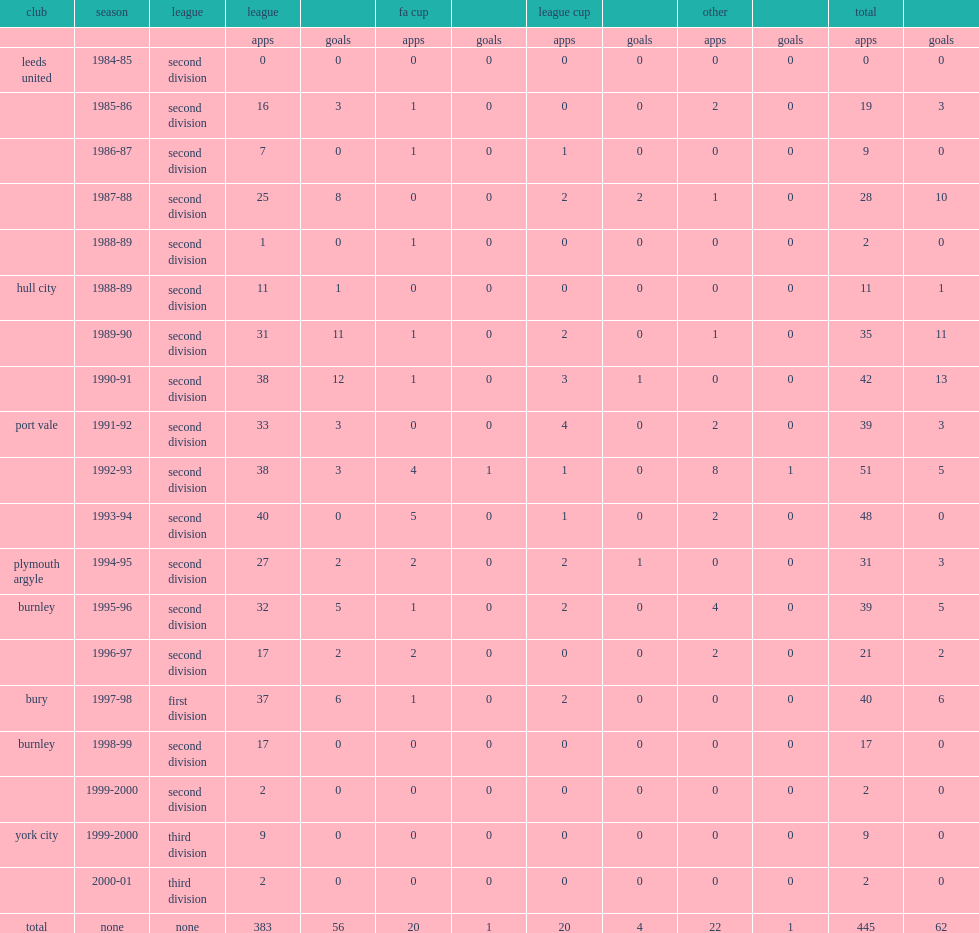How many goals did peter swan score in his career in the football league? 62.0. Would you be able to parse every entry in this table? {'header': ['club', 'season', 'league', 'league', '', 'fa cup', '', 'league cup', '', 'other', '', 'total', ''], 'rows': [['', '', '', 'apps', 'goals', 'apps', 'goals', 'apps', 'goals', 'apps', 'goals', 'apps', 'goals'], ['leeds united', '1984-85', 'second division', '0', '0', '0', '0', '0', '0', '0', '0', '0', '0'], ['', '1985-86', 'second division', '16', '3', '1', '0', '0', '0', '2', '0', '19', '3'], ['', '1986-87', 'second division', '7', '0', '1', '0', '1', '0', '0', '0', '9', '0'], ['', '1987-88', 'second division', '25', '8', '0', '0', '2', '2', '1', '0', '28', '10'], ['', '1988-89', 'second division', '1', '0', '1', '0', '0', '0', '0', '0', '2', '0'], ['hull city', '1988-89', 'second division', '11', '1', '0', '0', '0', '0', '0', '0', '11', '1'], ['', '1989-90', 'second division', '31', '11', '1', '0', '2', '0', '1', '0', '35', '11'], ['', '1990-91', 'second division', '38', '12', '1', '0', '3', '1', '0', '0', '42', '13'], ['port vale', '1991-92', 'second division', '33', '3', '0', '0', '4', '0', '2', '0', '39', '3'], ['', '1992-93', 'second division', '38', '3', '4', '1', '1', '0', '8', '1', '51', '5'], ['', '1993-94', 'second division', '40', '0', '5', '0', '1', '0', '2', '0', '48', '0'], ['plymouth argyle', '1994-95', 'second division', '27', '2', '2', '0', '2', '1', '0', '0', '31', '3'], ['burnley', '1995-96', 'second division', '32', '5', '1', '0', '2', '0', '4', '0', '39', '5'], ['', '1996-97', 'second division', '17', '2', '2', '0', '0', '0', '2', '0', '21', '2'], ['bury', '1997-98', 'first division', '37', '6', '1', '0', '2', '0', '0', '0', '40', '6'], ['burnley', '1998-99', 'second division', '17', '0', '0', '0', '0', '0', '0', '0', '17', '0'], ['', '1999-2000', 'second division', '2', '0', '0', '0', '0', '0', '0', '0', '2', '0'], ['york city', '1999-2000', 'third division', '9', '0', '0', '0', '0', '0', '0', '0', '9', '0'], ['', '2000-01', 'third division', '2', '0', '0', '0', '0', '0', '0', '0', '2', '0'], ['total', 'none', 'none', '383', '56', '20', '1', '20', '4', '22', '1', '445', '62']]} 